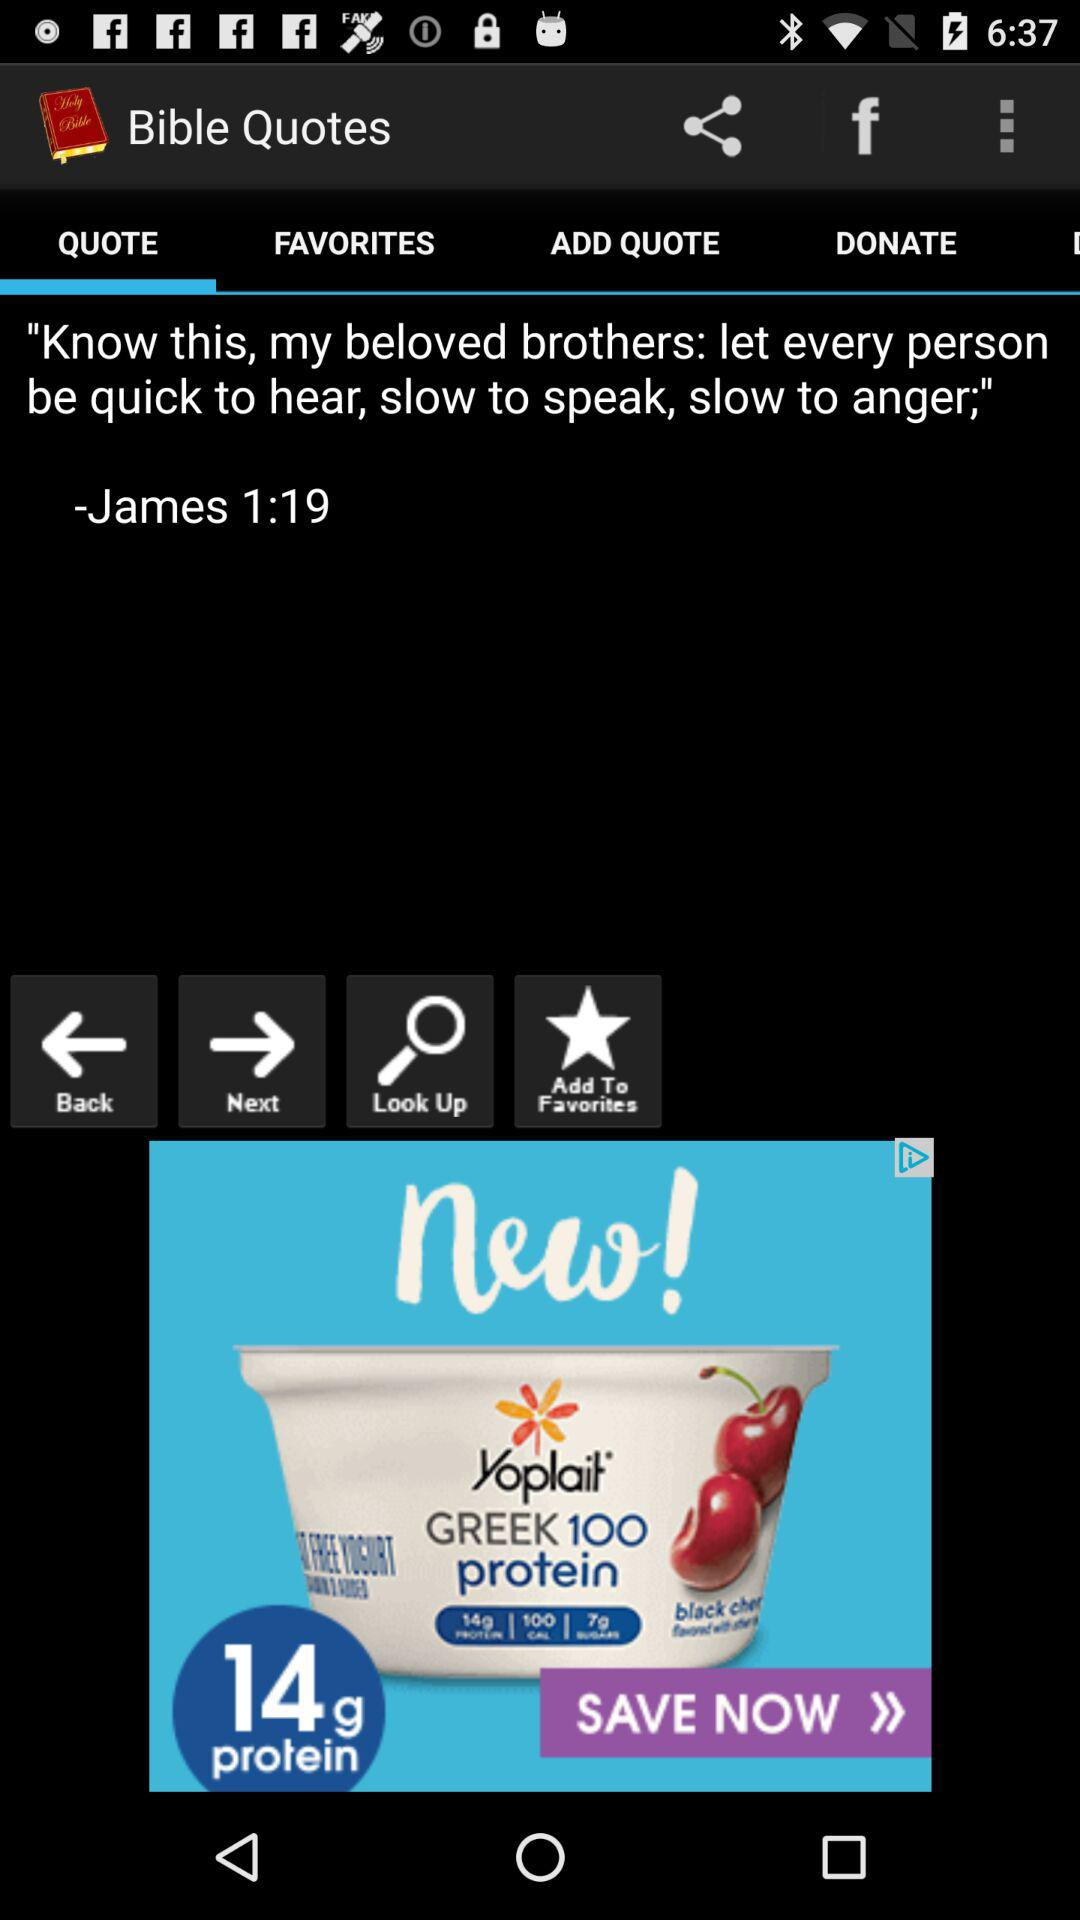Which tab is selected? The selected tab is "QUOTE". 